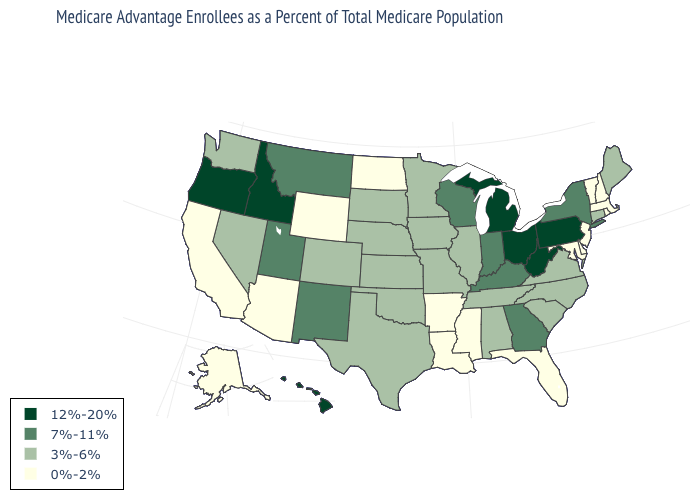Name the states that have a value in the range 0%-2%?
Write a very short answer. Alaska, Arkansas, Arizona, California, Delaware, Florida, Louisiana, Massachusetts, Maryland, Mississippi, North Dakota, New Hampshire, New Jersey, Rhode Island, Vermont, Wyoming. What is the value of Oregon?
Keep it brief. 12%-20%. Does the map have missing data?
Give a very brief answer. No. Which states have the lowest value in the USA?
Write a very short answer. Alaska, Arkansas, Arizona, California, Delaware, Florida, Louisiana, Massachusetts, Maryland, Mississippi, North Dakota, New Hampshire, New Jersey, Rhode Island, Vermont, Wyoming. What is the highest value in the West ?
Concise answer only. 12%-20%. Does Wyoming have the same value as Rhode Island?
Keep it brief. Yes. What is the highest value in the South ?
Quick response, please. 12%-20%. How many symbols are there in the legend?
Write a very short answer. 4. Among the states that border Maine , which have the lowest value?
Be succinct. New Hampshire. Does New Jersey have a lower value than Rhode Island?
Keep it brief. No. Does North Carolina have a higher value than North Dakota?
Quick response, please. Yes. Which states hav the highest value in the Northeast?
Write a very short answer. Pennsylvania. Does Washington have the same value as Louisiana?
Keep it brief. No. Name the states that have a value in the range 3%-6%?
Quick response, please. Alabama, Colorado, Connecticut, Iowa, Illinois, Kansas, Maine, Minnesota, Missouri, North Carolina, Nebraska, Nevada, Oklahoma, South Carolina, South Dakota, Tennessee, Texas, Virginia, Washington. Does Washington have the highest value in the USA?
Keep it brief. No. 